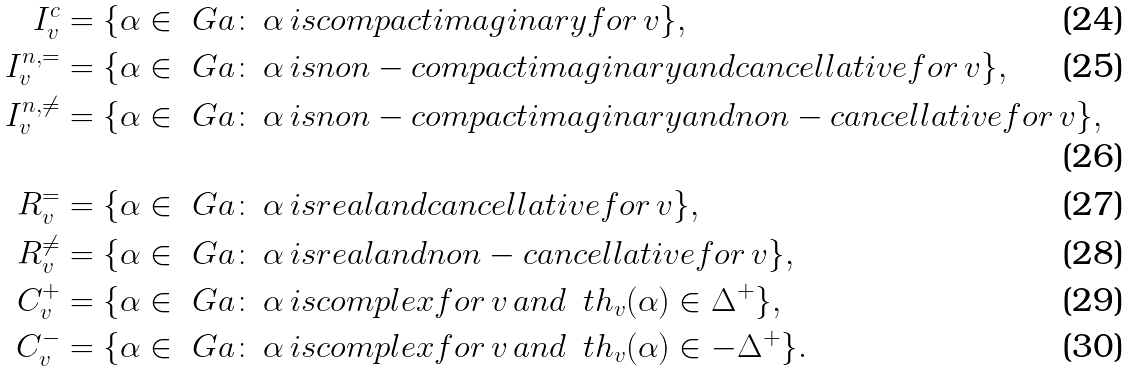<formula> <loc_0><loc_0><loc_500><loc_500>I ^ { c } _ { v } & = \{ \alpha \in \ G a \colon \, \alpha \, i s c o m p a c t i m a g i n a r y f o r \, v \} , \\ I _ { v } ^ { n , = } & = \{ \alpha \in \ G a \colon \, \alpha \, i s n o n - c o m p a c t i m a g i n a r y a n d c a n c e l l a t i v e f o r \, v \} , \\ I _ { v } ^ { n , \neq } & = \{ \alpha \in \ G a \colon \, \alpha \, i s n o n - c o m p a c t i m a g i n a r y a n d n o n - c a n c e l l a t i v e f o r \, v \} , \\ R _ { v } ^ { = } & = \{ \alpha \in \ G a \colon \, \alpha \, i s r e a l a n d c a n c e l l a t i v e f o r \, v \} , \\ R _ { v } ^ { \neq } & = \{ \alpha \in \ G a \colon \, \alpha \, i s r e a l a n d n o n - c a n c e l l a t i v e f o r \, v \} , \\ C _ { v } ^ { + } & = \{ \alpha \in \ G a \colon \, \alpha \, i s c o m p l e x f o r \, v \, a n d \, \ t h _ { v } ( \alpha ) \in \Delta ^ { + } \} , \\ C _ { v } ^ { - } & = \{ \alpha \in \ G a \colon \, \alpha \, i s c o m p l e x f o r \, v \, a n d \, \ t h _ { v } ( \alpha ) \in - \Delta ^ { + } \} .</formula> 